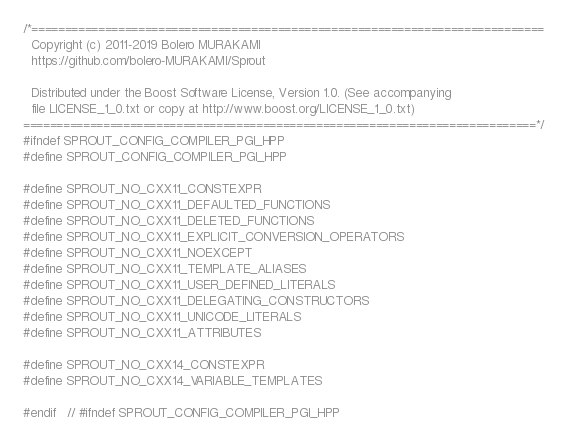Convert code to text. <code><loc_0><loc_0><loc_500><loc_500><_C++_>/*=============================================================================
  Copyright (c) 2011-2019 Bolero MURAKAMI
  https://github.com/bolero-MURAKAMI/Sprout

  Distributed under the Boost Software License, Version 1.0. (See accompanying
  file LICENSE_1_0.txt or copy at http://www.boost.org/LICENSE_1_0.txt)
=============================================================================*/
#ifndef SPROUT_CONFIG_COMPILER_PGI_HPP
#define SPROUT_CONFIG_COMPILER_PGI_HPP

#define SPROUT_NO_CXX11_CONSTEXPR
#define SPROUT_NO_CXX11_DEFAULTED_FUNCTIONS
#define SPROUT_NO_CXX11_DELETED_FUNCTIONS
#define SPROUT_NO_CXX11_EXPLICIT_CONVERSION_OPERATORS
#define SPROUT_NO_CXX11_NOEXCEPT
#define SPROUT_NO_CXX11_TEMPLATE_ALIASES
#define SPROUT_NO_CXX11_USER_DEFINED_LITERALS
#define SPROUT_NO_CXX11_DELEGATING_CONSTRUCTORS
#define SPROUT_NO_CXX11_UNICODE_LITERALS
#define SPROUT_NO_CXX11_ATTRIBUTES

#define SPROUT_NO_CXX14_CONSTEXPR
#define SPROUT_NO_CXX14_VARIABLE_TEMPLATES

#endif	// #ifndef SPROUT_CONFIG_COMPILER_PGI_HPP
</code> 